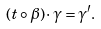Convert formula to latex. <formula><loc_0><loc_0><loc_500><loc_500>( t \circ \beta ) \cdot \gamma = \gamma ^ { \prime } .</formula> 